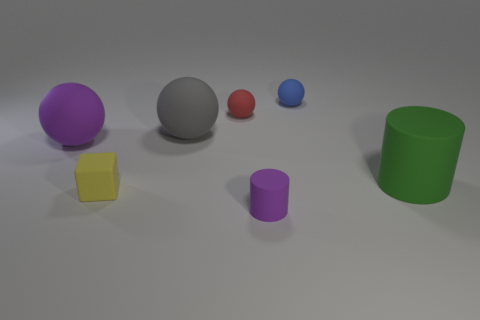Subtract 4 balls. How many balls are left? 0 Add 2 small purple matte cylinders. How many objects exist? 9 Subtract all cubes. How many objects are left? 6 Subtract all red balls. How many balls are left? 3 Add 1 blocks. How many blocks are left? 2 Add 3 matte spheres. How many matte spheres exist? 7 Subtract 1 purple cylinders. How many objects are left? 6 Subtract all blue balls. Subtract all yellow cubes. How many balls are left? 3 Subtract all gray cubes. How many green cylinders are left? 1 Subtract all big purple rubber cubes. Subtract all tiny red matte objects. How many objects are left? 6 